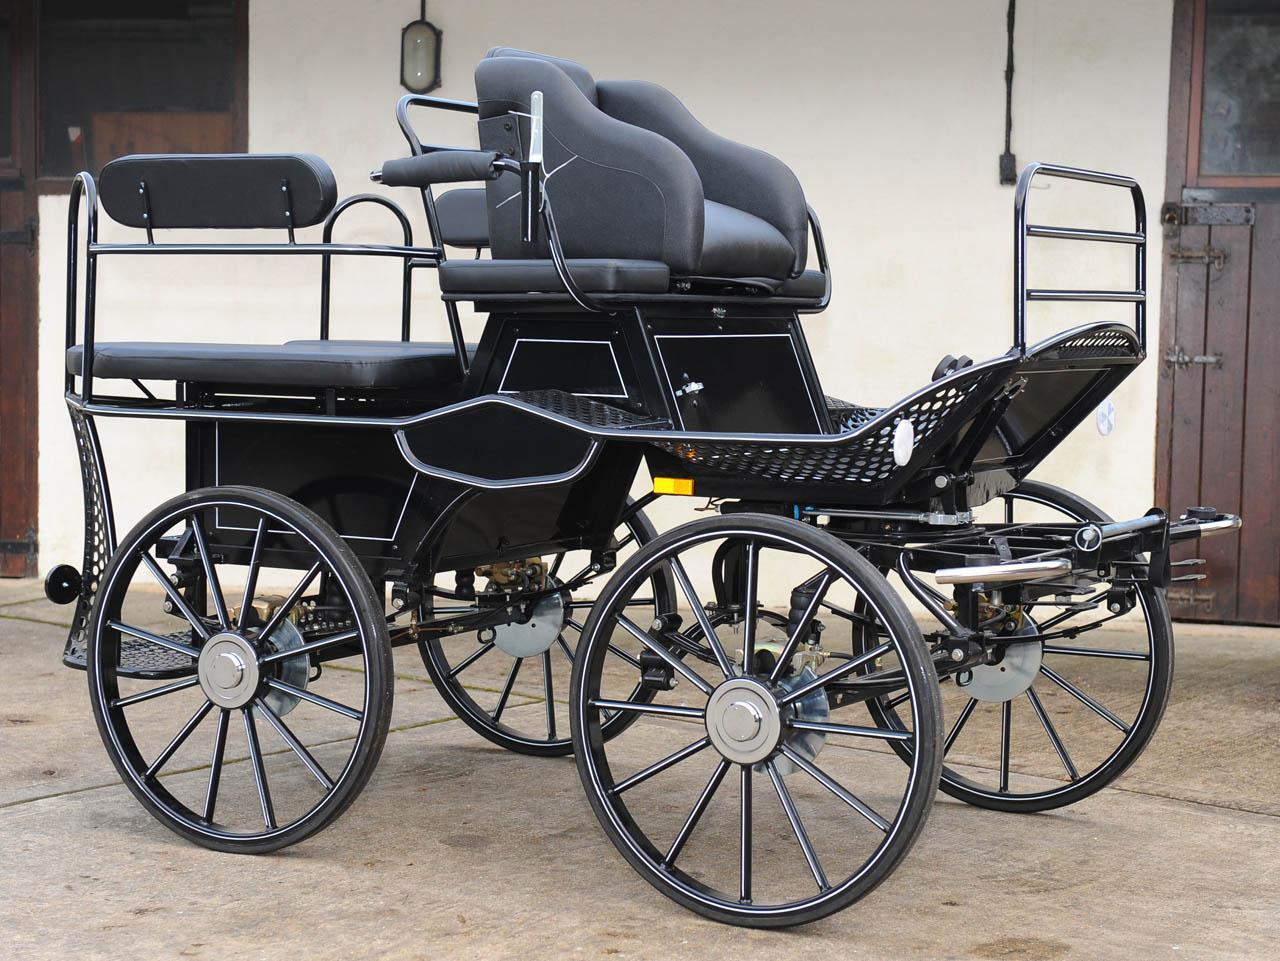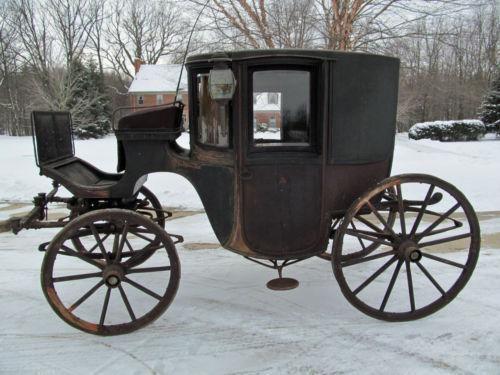The first image is the image on the left, the second image is the image on the right. Given the left and right images, does the statement "The carriages in both photos are facing to the left." hold true? Answer yes or no. No. The first image is the image on the left, the second image is the image on the right. Examine the images to the left and right. Is the description "At least one cart is facing toward the right." accurate? Answer yes or no. Yes. 